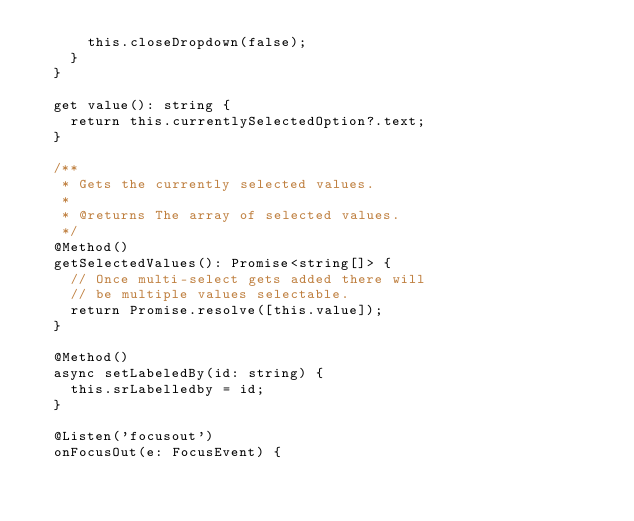Convert code to text. <code><loc_0><loc_0><loc_500><loc_500><_TypeScript_>      this.closeDropdown(false);
    }
  }

  get value(): string {
    return this.currentlySelectedOption?.text;
  }

  /**
   * Gets the currently selected values.
   *
   * @returns The array of selected values.
   */
  @Method()
  getSelectedValues(): Promise<string[]> {
    // Once multi-select gets added there will
    // be multiple values selectable.
    return Promise.resolve([this.value]);
  }

  @Method()
  async setLabeledBy(id: string) {
    this.srLabelledby = id;
  }

  @Listen('focusout')
  onFocusOut(e: FocusEvent) {</code> 